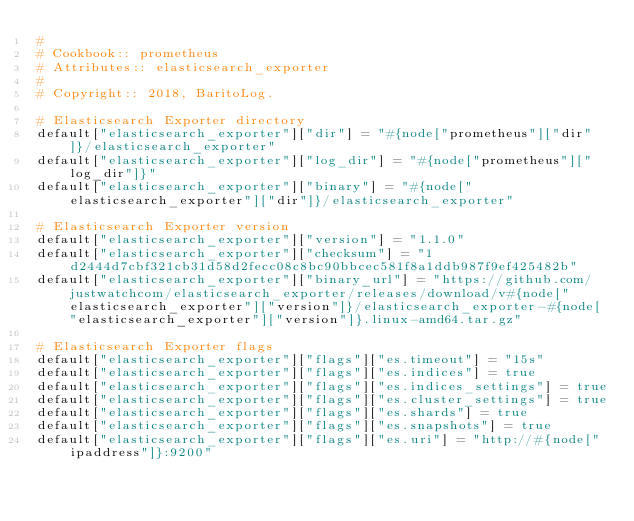Convert code to text. <code><loc_0><loc_0><loc_500><loc_500><_Ruby_>#
# Cookbook:: prometheus
# Attributes:: elasticsearch_exporter
#
# Copyright:: 2018, BaritoLog.

# Elasticsearch Exporter directory
default["elasticsearch_exporter"]["dir"] = "#{node["prometheus"]["dir"]}/elasticsearch_exporter"
default["elasticsearch_exporter"]["log_dir"] = "#{node["prometheus"]["log_dir"]}"
default["elasticsearch_exporter"]["binary"] = "#{node["elasticsearch_exporter"]["dir"]}/elasticsearch_exporter"

# Elasticsearch Exporter version
default["elasticsearch_exporter"]["version"] = "1.1.0"
default["elasticsearch_exporter"]["checksum"] = "1d2444d7cbf321cb31d58d2fecc08c8bc90bbcec581f8a1ddb987f9ef425482b"
default["elasticsearch_exporter"]["binary_url"] = "https://github.com/justwatchcom/elasticsearch_exporter/releases/download/v#{node["elasticsearch_exporter"]["version"]}/elasticsearch_exporter-#{node["elasticsearch_exporter"]["version"]}.linux-amd64.tar.gz"

# Elasticsearch Exporter flags
default["elasticsearch_exporter"]["flags"]["es.timeout"] = "15s"
default["elasticsearch_exporter"]["flags"]["es.indices"] = true
default["elasticsearch_exporter"]["flags"]["es.indices_settings"] = true
default["elasticsearch_exporter"]["flags"]["es.cluster_settings"] = true
default["elasticsearch_exporter"]["flags"]["es.shards"] = true
default["elasticsearch_exporter"]["flags"]["es.snapshots"] = true
default["elasticsearch_exporter"]["flags"]["es.uri"] = "http://#{node["ipaddress"]}:9200"
</code> 